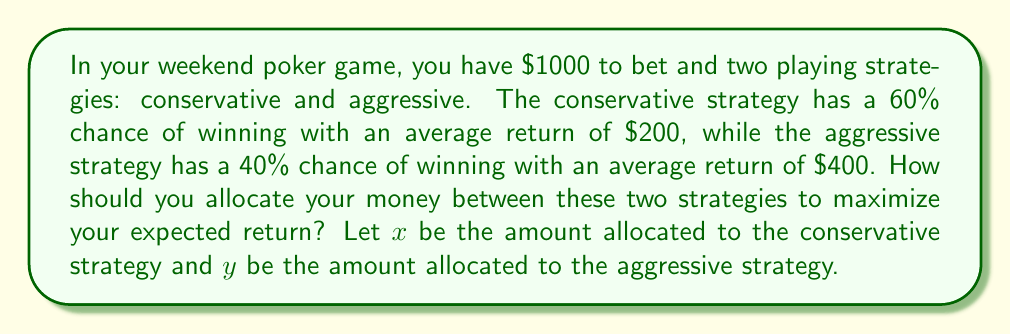Give your solution to this math problem. Let's approach this step-by-step using linear equations:

1) First, we need to set up our constraints:
   $$x + y = 1000$$ (total amount to bet)
   $$x \geq 0, y \geq 0$$ (non-negative bets)

2) Now, let's create an equation for the expected return:
   Conservative strategy: $0.60 \cdot 200 \cdot \frac{x}{1000} = 0.12x$
   Aggressive strategy: $0.40 \cdot 400 \cdot \frac{y}{1000} = 0.16y$

3) Total expected return: $E = 0.12x + 0.16y$

4) Our goal is to maximize E subject to our constraints. This is a linear programming problem.

5) The optimal solution will be at one of the extreme points of our feasible region. These points are:
   (0, 1000) and (1000, 0)

6) Let's evaluate E at these points:
   At (0, 1000): $E = 0.12(0) + 0.16(1000) = 160$
   At (1000, 0): $E = 0.12(1000) + 0.16(0) = 120$

7) The maximum expected return is at (0, 1000), which means allocating all $1000 to the aggressive strategy.
Answer: Allocate all $1000 to the aggressive strategy. 